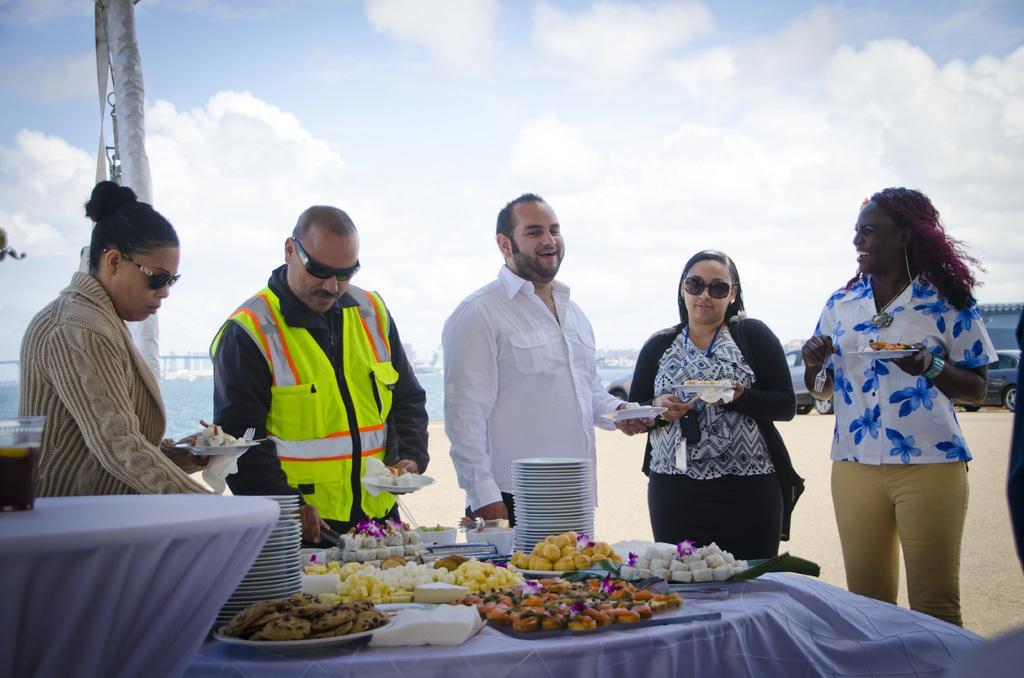In one or two sentences, can you explain what this image depicts? In this image we can see few people standing and holding plates with food items and there are tables in front of them, on a table there are few plates and few food items, a glass with drink on the other table, there is a pole and few vehicles on the ground and there is water and the sky with clouds in the background. 